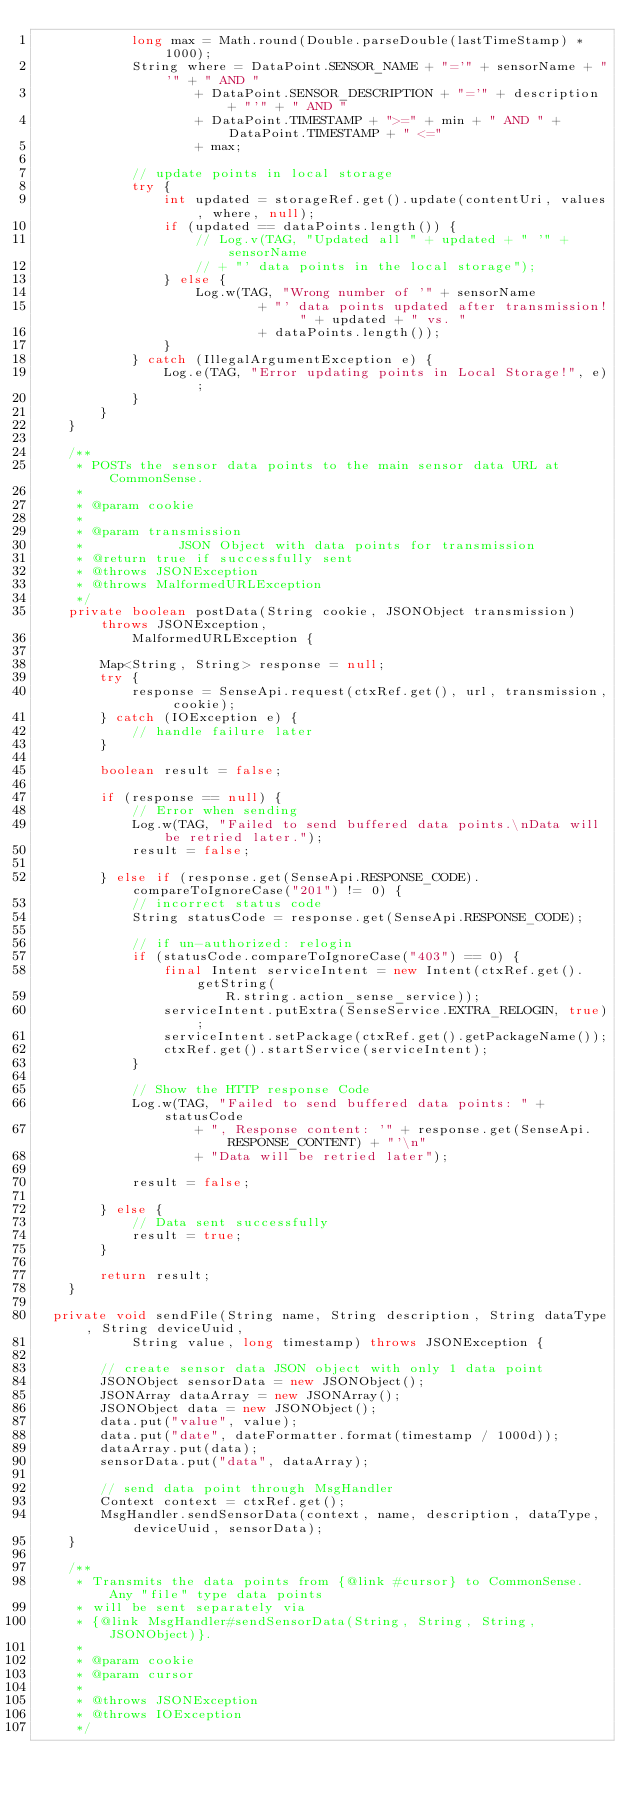<code> <loc_0><loc_0><loc_500><loc_500><_Java_>            long max = Math.round(Double.parseDouble(lastTimeStamp) * 1000);
            String where = DataPoint.SENSOR_NAME + "='" + sensorName + "'" + " AND "
                    + DataPoint.SENSOR_DESCRIPTION + "='" + description + "'" + " AND "
                    + DataPoint.TIMESTAMP + ">=" + min + " AND " + DataPoint.TIMESTAMP + " <="
                    + max;

            // update points in local storage
            try {
                int updated = storageRef.get().update(contentUri, values, where, null);
                if (updated == dataPoints.length()) {
                    // Log.v(TAG, "Updated all " + updated + " '" + sensorName
                    // + "' data points in the local storage");
                } else {
                    Log.w(TAG, "Wrong number of '" + sensorName
                            + "' data points updated after transmission! " + updated + " vs. "
                            + dataPoints.length());
                }
            } catch (IllegalArgumentException e) {
                Log.e(TAG, "Error updating points in Local Storage!", e);
            }
        }
    }

    /**
     * POSTs the sensor data points to the main sensor data URL at CommonSense.
     * 
     * @param cookie
     * 
     * @param transmission
     *            JSON Object with data points for transmission
     * @return true if successfully sent
     * @throws JSONException
     * @throws MalformedURLException
     */
    private boolean postData(String cookie, JSONObject transmission) throws JSONException,
            MalformedURLException {

        Map<String, String> response = null;
        try {
            response = SenseApi.request(ctxRef.get(), url, transmission, cookie);
        } catch (IOException e) {
            // handle failure later
        }

        boolean result = false;

        if (response == null) {
            // Error when sending
            Log.w(TAG, "Failed to send buffered data points.\nData will be retried later.");
            result = false;

        } else if (response.get(SenseApi.RESPONSE_CODE).compareToIgnoreCase("201") != 0) {
            // incorrect status code
            String statusCode = response.get(SenseApi.RESPONSE_CODE);

            // if un-authorized: relogin
            if (statusCode.compareToIgnoreCase("403") == 0) {
                final Intent serviceIntent = new Intent(ctxRef.get().getString(
                        R.string.action_sense_service));
                serviceIntent.putExtra(SenseService.EXTRA_RELOGIN, true);
                serviceIntent.setPackage(ctxRef.get().getPackageName());
                ctxRef.get().startService(serviceIntent);
            }

            // Show the HTTP response Code
            Log.w(TAG, "Failed to send buffered data points: " + statusCode
                    + ", Response content: '" + response.get(SenseApi.RESPONSE_CONTENT) + "'\n"
                    + "Data will be retried later");

            result = false;

        } else {
            // Data sent successfully
            result = true;
        }

        return result;
    }

	private void sendFile(String name, String description, String dataType, String deviceUuid,
            String value, long timestamp) throws JSONException {

        // create sensor data JSON object with only 1 data point
        JSONObject sensorData = new JSONObject();
        JSONArray dataArray = new JSONArray();
        JSONObject data = new JSONObject();
        data.put("value", value);
        data.put("date", dateFormatter.format(timestamp / 1000d));
        dataArray.put(data);
        sensorData.put("data", dataArray);

        // send data point through MsgHandler
        Context context = ctxRef.get();
        MsgHandler.sendSensorData(context, name, description, dataType, deviceUuid, sensorData);
    }

    /**
     * Transmits the data points from {@link #cursor} to CommonSense. Any "file" type data points
     * will be sent separately via
     * {@link MsgHandler#sendSensorData(String, String, String, JSONObject)}.
     * 
     * @param cookie
     * @param cursor
     * 
     * @throws JSONException
     * @throws IOException
     */</code> 